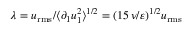Convert formula to latex. <formula><loc_0><loc_0><loc_500><loc_500>\lambda = u _ { r m s } / \langle \partial _ { 1 } u _ { 1 } ^ { 2 } \rangle ^ { 1 / 2 } = ( 1 5 \, \nu / \varepsilon ) ^ { 1 / 2 } u _ { r m s }</formula> 